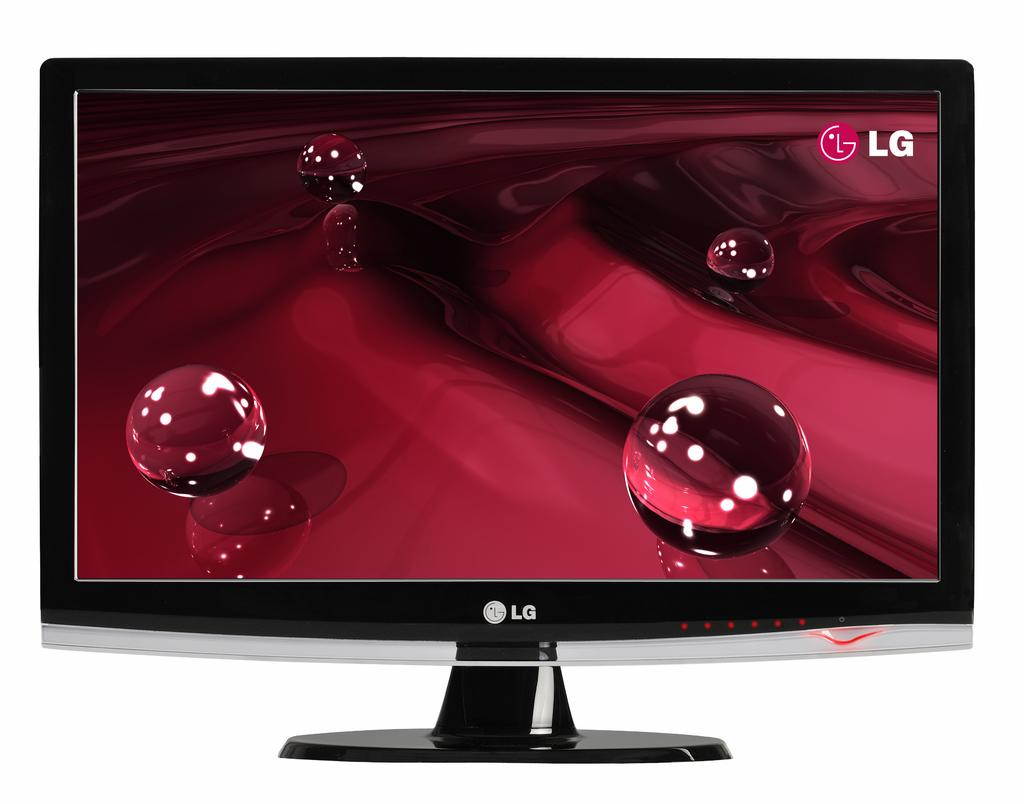<image>
Write a terse but informative summary of the picture. An LG monitor displaying a ripple effect graphic with clear orbs. 